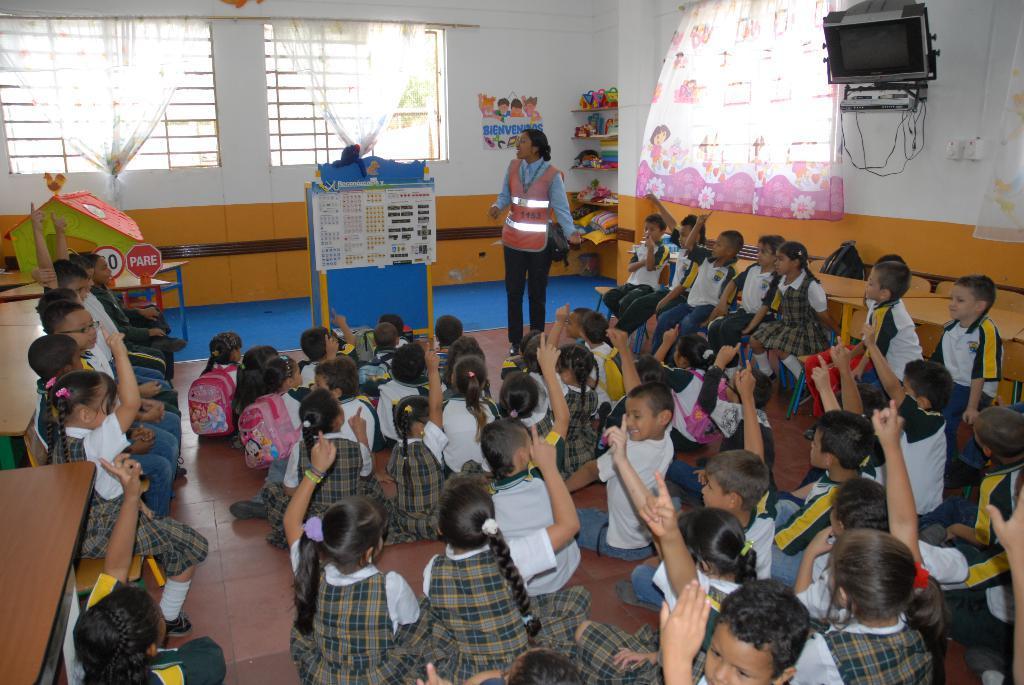In one or two sentences, can you explain what this image depicts? This image is taken in a classroom. In this image we can see the kids sitting on the floor and some are sitting on the benches. There is also a woman standing. Image also consists of windows with curtains, depiction of a house, some toys, switch board and also the poster attached to the plain wall. 